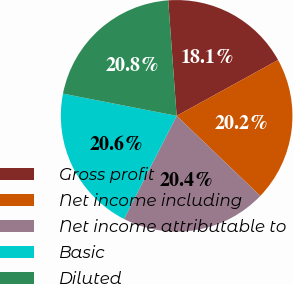Convert chart to OTSL. <chart><loc_0><loc_0><loc_500><loc_500><pie_chart><fcel>Gross profit<fcel>Net income including<fcel>Net income attributable to<fcel>Basic<fcel>Diluted<nl><fcel>18.15%<fcel>20.16%<fcel>20.36%<fcel>20.56%<fcel>20.77%<nl></chart> 